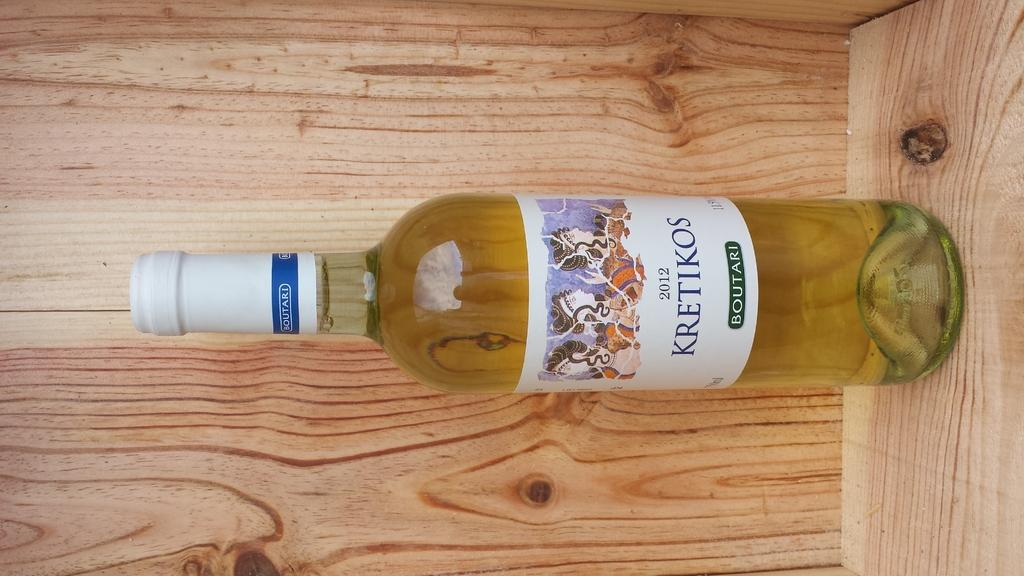What is the main object in the image? There is a wine bottle in the image. Where is the wine bottle located? The wine bottle is on a wooden shelf. What feature can be found on the wine bottle? There is a knob on the wine bottle. Is there any additional information on the wine bottle? Yes, there is a sticker on the wine bottle. Can you tell me how many parents are visible in the image? There are no parents present in the image; it features a wine bottle on a wooden shelf. What type of twig is used as a decoration on the wine bottle? There is no twig present on the wine bottle in the image. 